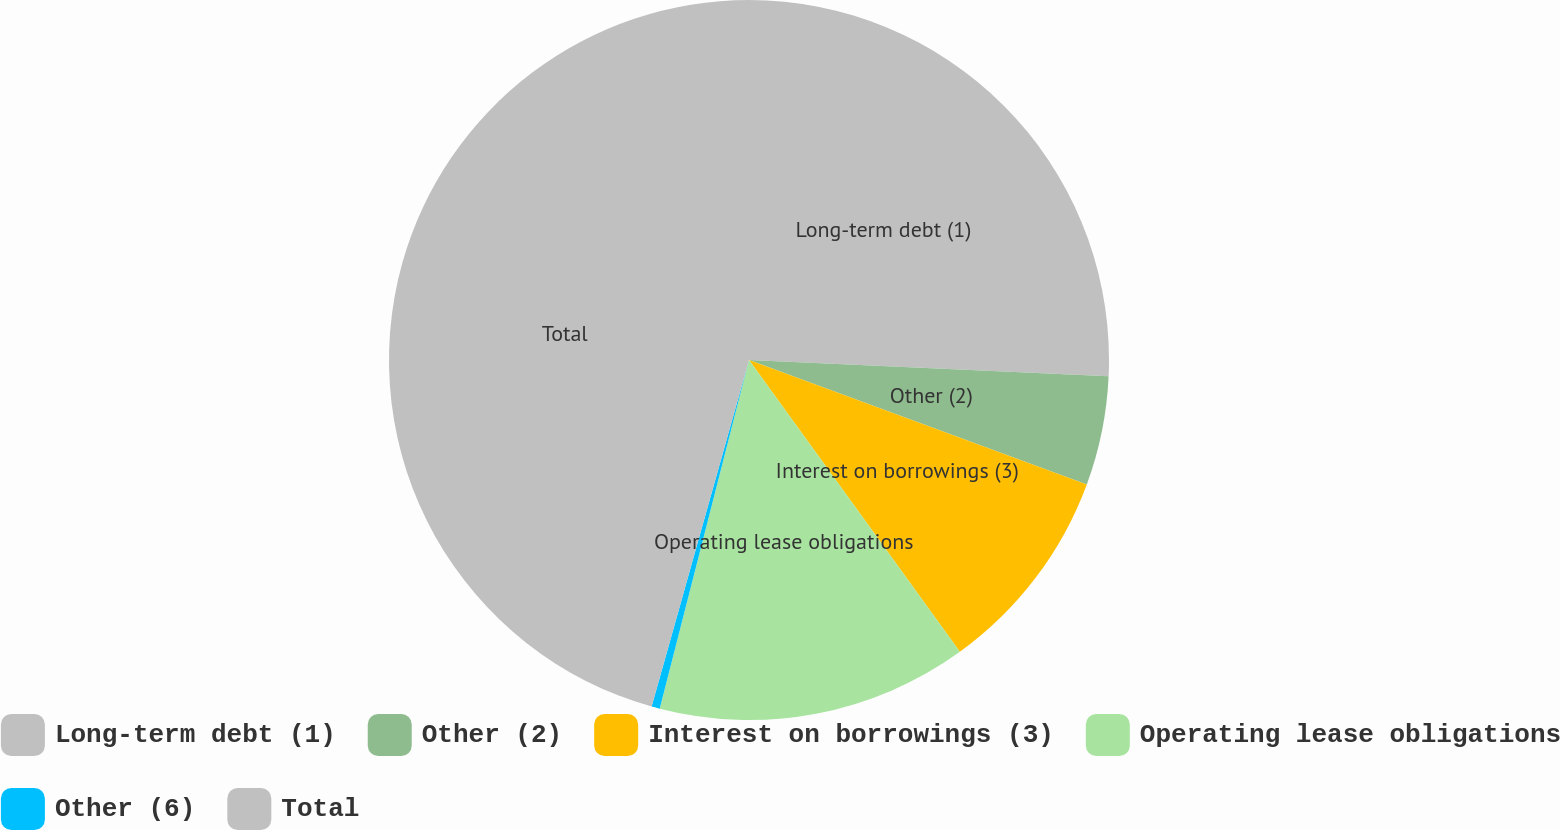<chart> <loc_0><loc_0><loc_500><loc_500><pie_chart><fcel>Long-term debt (1)<fcel>Other (2)<fcel>Interest on borrowings (3)<fcel>Operating lease obligations<fcel>Other (6)<fcel>Total<nl><fcel>25.72%<fcel>4.9%<fcel>9.42%<fcel>13.95%<fcel>0.37%<fcel>45.64%<nl></chart> 